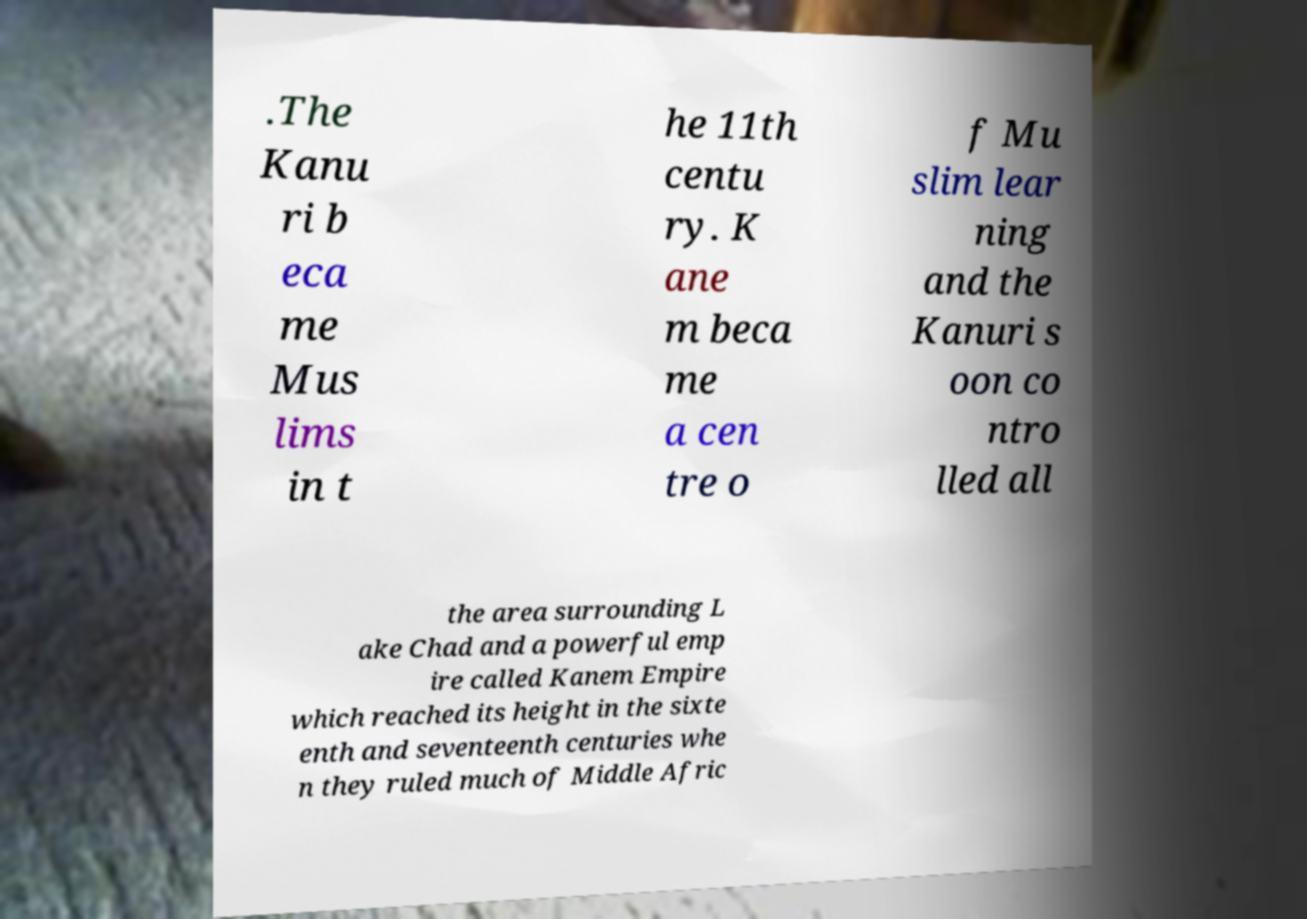I need the written content from this picture converted into text. Can you do that? .The Kanu ri b eca me Mus lims in t he 11th centu ry. K ane m beca me a cen tre o f Mu slim lear ning and the Kanuri s oon co ntro lled all the area surrounding L ake Chad and a powerful emp ire called Kanem Empire which reached its height in the sixte enth and seventeenth centuries whe n they ruled much of Middle Afric 